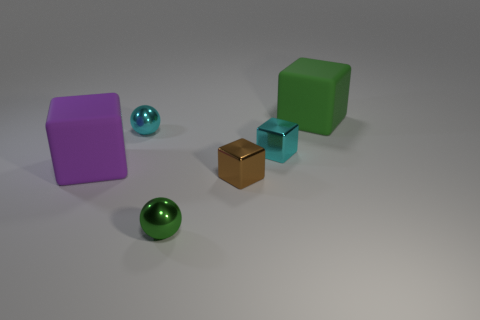Add 2 small cyan shiny cubes. How many objects exist? 8 Subtract all brown shiny blocks. How many blocks are left? 3 Subtract all purple blocks. How many blocks are left? 3 Subtract 3 cubes. How many cubes are left? 1 Subtract all yellow cubes. Subtract all red balls. How many cubes are left? 4 Subtract all blue spheres. How many gray cubes are left? 0 Subtract all tiny green matte cylinders. Subtract all small brown metal objects. How many objects are left? 5 Add 4 brown shiny blocks. How many brown shiny blocks are left? 5 Add 2 brown things. How many brown things exist? 3 Subtract 0 cyan cylinders. How many objects are left? 6 